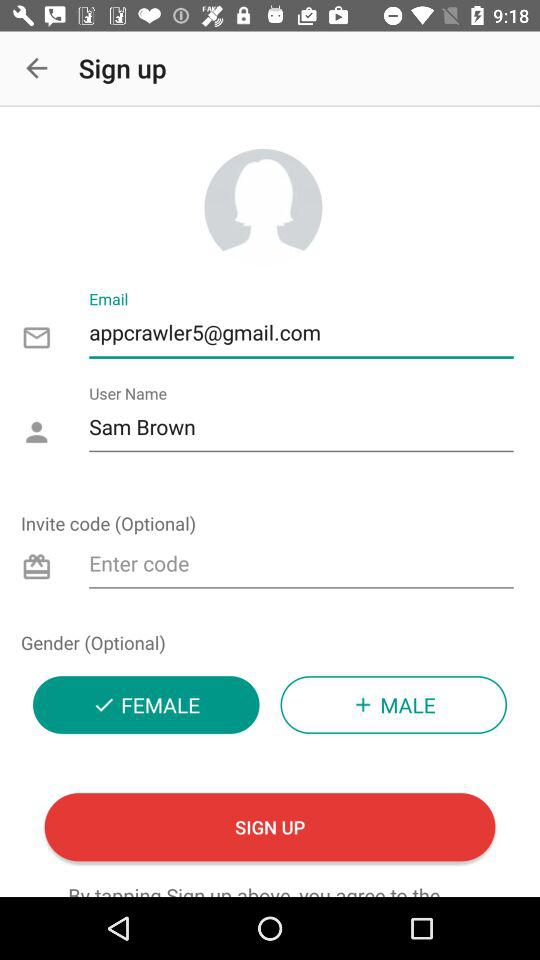What is the given email address? The given email address is appcrawler5@gmail.com. 